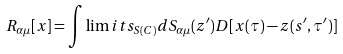Convert formula to latex. <formula><loc_0><loc_0><loc_500><loc_500>R _ { \alpha \mu } [ x ] = \int \lim i t s _ { S ( C ) } d S _ { \alpha \mu } ( z ^ { \prime } ) D [ x ( \tau ) - z ( s ^ { \prime } , \tau ^ { \prime } ) ]</formula> 